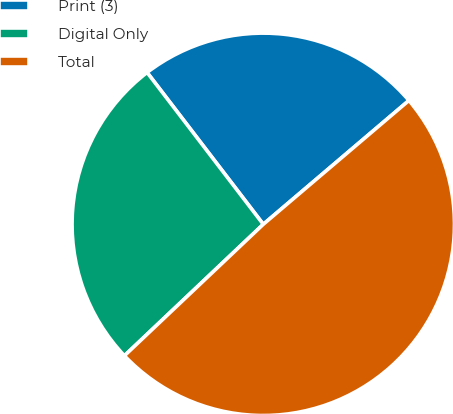Convert chart to OTSL. <chart><loc_0><loc_0><loc_500><loc_500><pie_chart><fcel>Print (3)<fcel>Digital Only<fcel>Total<nl><fcel>24.18%<fcel>26.67%<fcel>49.15%<nl></chart> 